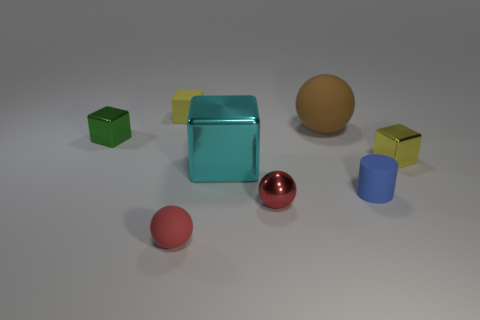What can you tell me about the lighting and shadows in the image? The image has a soft, diffuse lighting that creates gentle shadows below and to the right of the objects, indicating that the main light source is to the top left. The softness of the shadows suggests an overcast light situation or a diffused artificial light source, which is typical in a studio setup. 